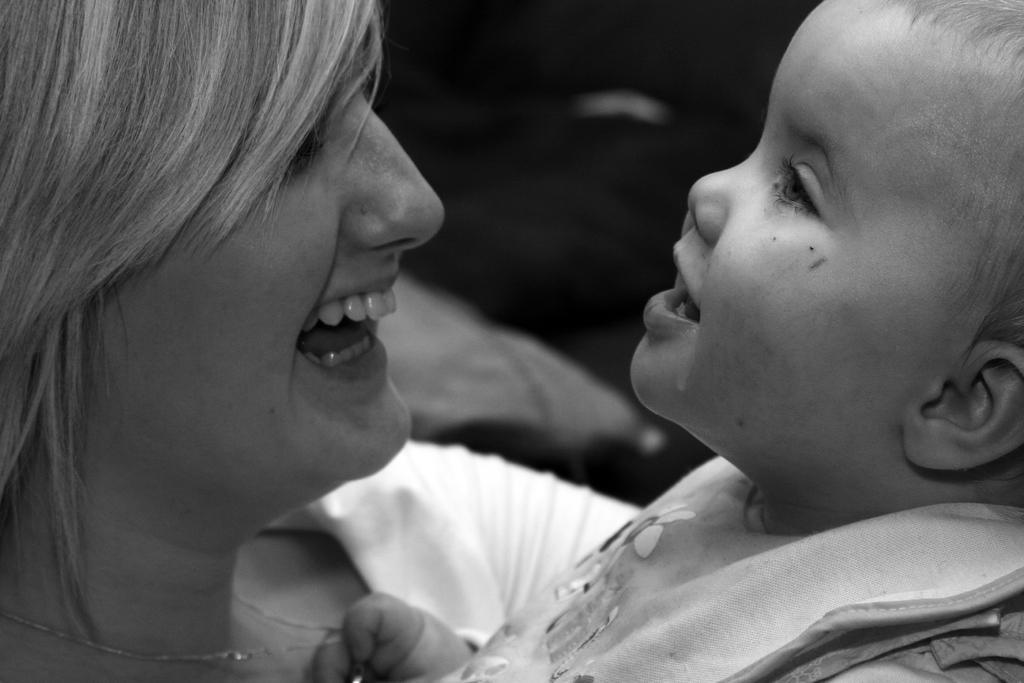Describe this image in one or two sentences. In this image there are two persons truncated, there are person smiling, the background of the image is blurred. 